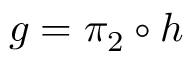Convert formula to latex. <formula><loc_0><loc_0><loc_500><loc_500>g = \pi _ { 2 } \circ h</formula> 